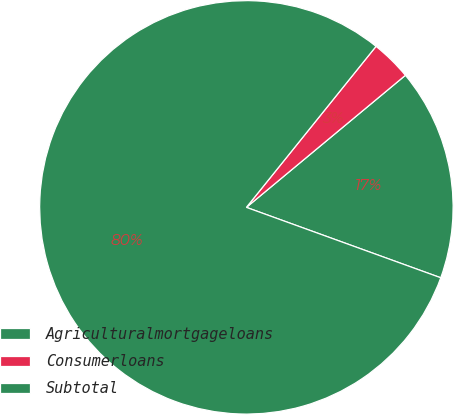Convert chart to OTSL. <chart><loc_0><loc_0><loc_500><loc_500><pie_chart><fcel>Agriculturalmortgageloans<fcel>Consumerloans<fcel>Subtotal<nl><fcel>16.56%<fcel>3.18%<fcel>80.25%<nl></chart> 